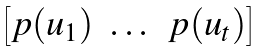Convert formula to latex. <formula><loc_0><loc_0><loc_500><loc_500>\begin{bmatrix} p ( u _ { 1 } ) & \dots & p ( u _ { t } ) \end{bmatrix}</formula> 